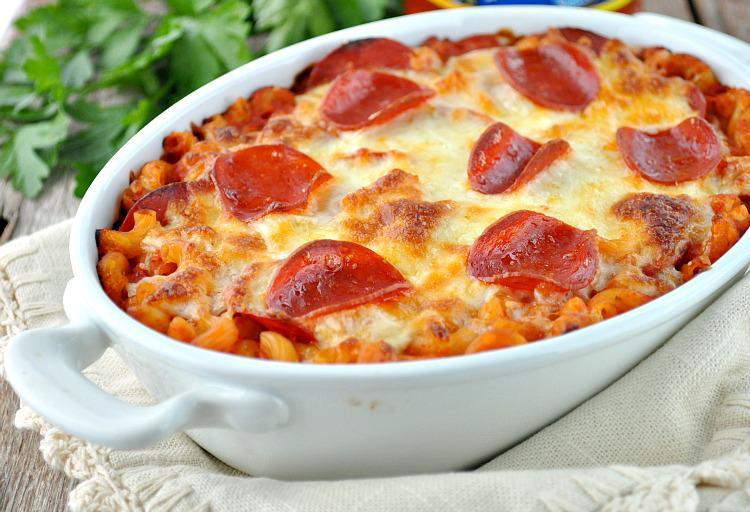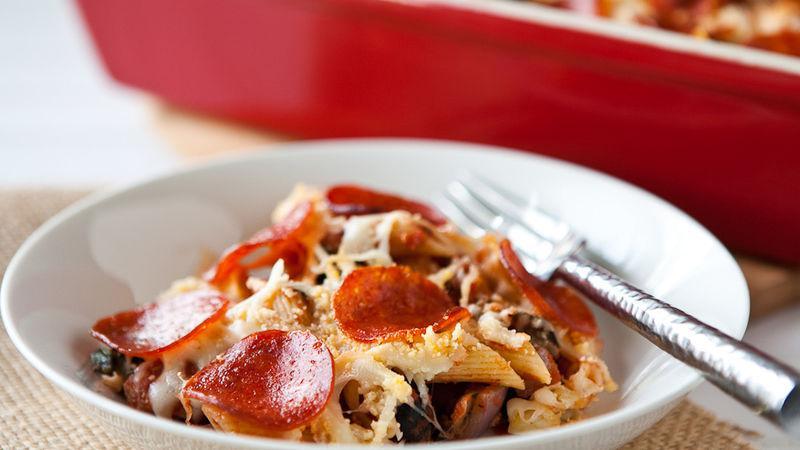The first image is the image on the left, the second image is the image on the right. For the images shown, is this caption "The left image shows a casserole in a rectangular white dish with a piece of silverware lying next to it on the left." true? Answer yes or no. No. The first image is the image on the left, the second image is the image on the right. Evaluate the accuracy of this statement regarding the images: "The food in the image on the left is sitting in a white square casserole dish.". Is it true? Answer yes or no. No. 